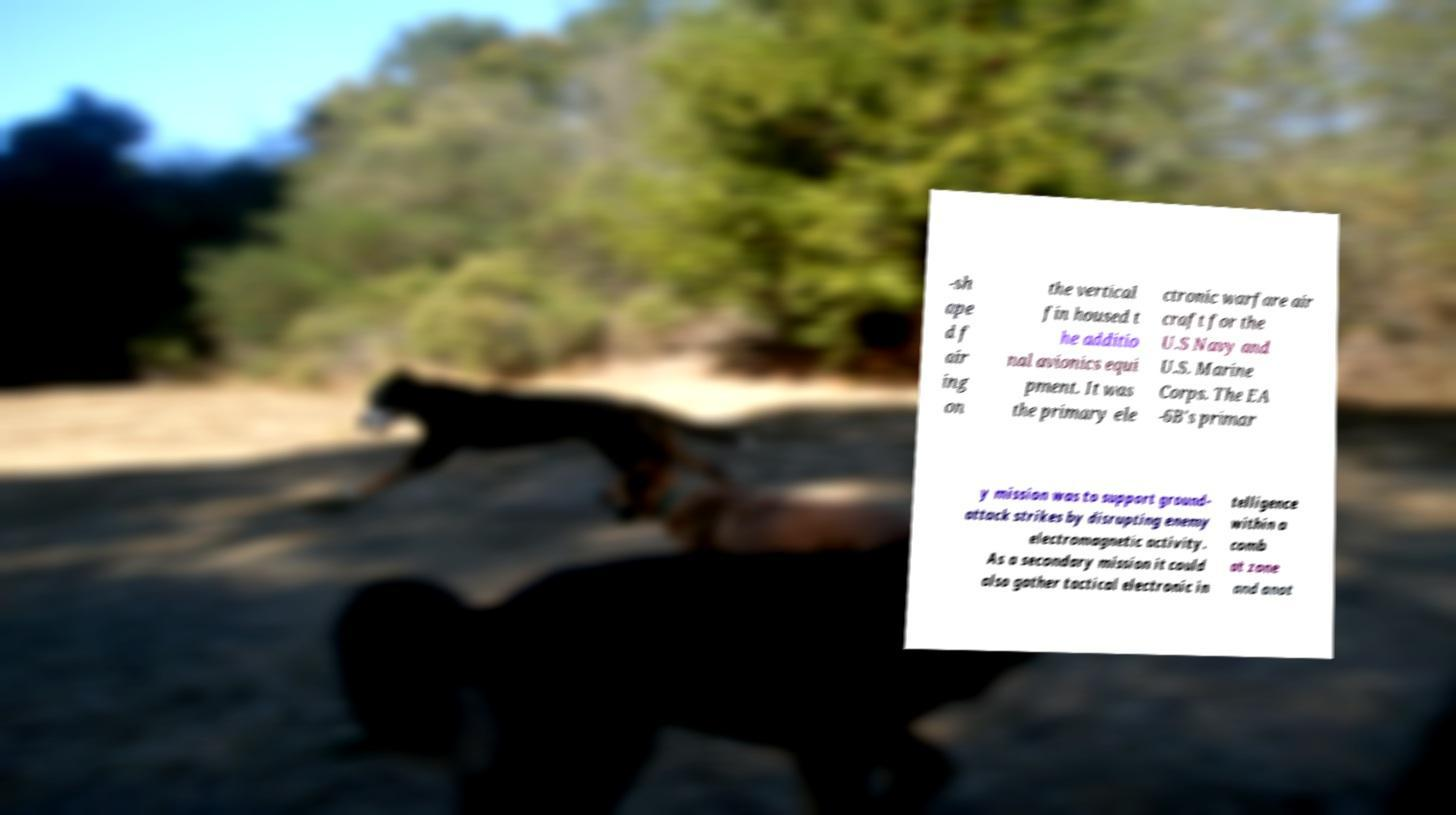Can you read and provide the text displayed in the image?This photo seems to have some interesting text. Can you extract and type it out for me? -sh ape d f air ing on the vertical fin housed t he additio nal avionics equi pment. It was the primary ele ctronic warfare air craft for the U.S Navy and U.S. Marine Corps. The EA -6B's primar y mission was to support ground- attack strikes by disrupting enemy electromagnetic activity. As a secondary mission it could also gather tactical electronic in telligence within a comb at zone and anot 